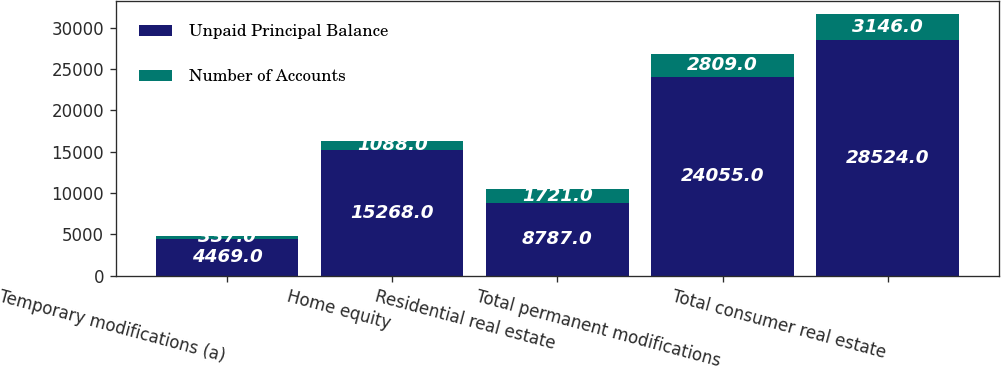<chart> <loc_0><loc_0><loc_500><loc_500><stacked_bar_chart><ecel><fcel>Temporary modifications (a)<fcel>Home equity<fcel>Residential real estate<fcel>Total permanent modifications<fcel>Total consumer real estate<nl><fcel>Unpaid Principal Balance<fcel>4469<fcel>15268<fcel>8787<fcel>24055<fcel>28524<nl><fcel>Number of Accounts<fcel>337<fcel>1088<fcel>1721<fcel>2809<fcel>3146<nl></chart> 